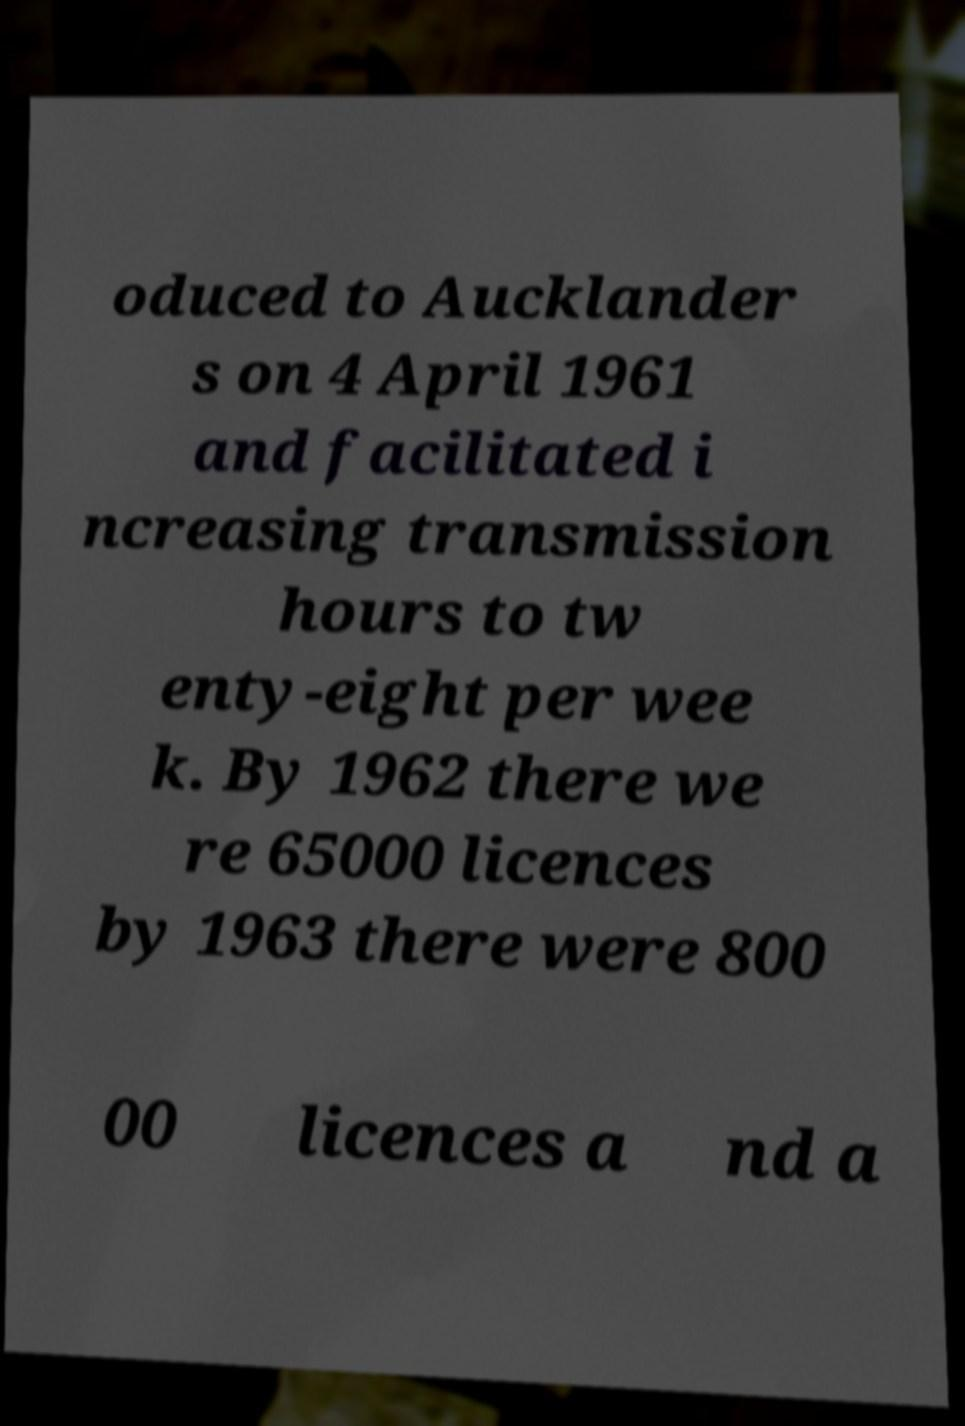What messages or text are displayed in this image? I need them in a readable, typed format. oduced to Aucklander s on 4 April 1961 and facilitated i ncreasing transmission hours to tw enty-eight per wee k. By 1962 there we re 65000 licences by 1963 there were 800 00 licences a nd a 